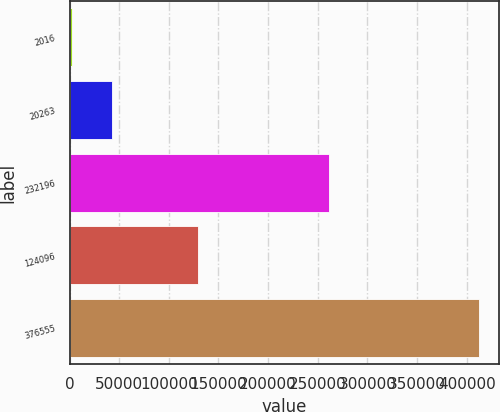Convert chart. <chart><loc_0><loc_0><loc_500><loc_500><bar_chart><fcel>2016<fcel>20263<fcel>232196<fcel>124096<fcel>376555<nl><fcel>2015<fcel>43044.9<fcel>261520<fcel>128969<fcel>412314<nl></chart> 